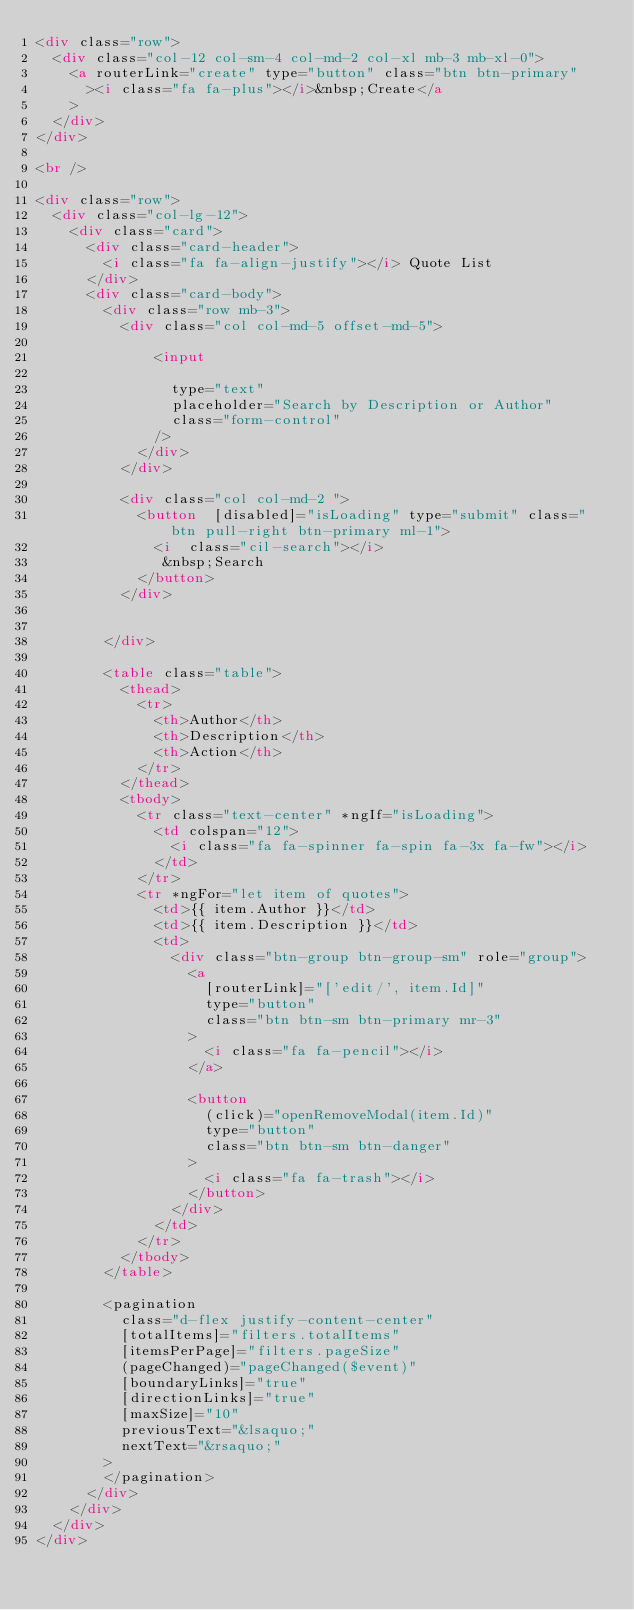<code> <loc_0><loc_0><loc_500><loc_500><_HTML_><div class="row">
  <div class="col-12 col-sm-4 col-md-2 col-xl mb-3 mb-xl-0">
    <a routerLink="create" type="button" class="btn btn-primary"
      ><i class="fa fa-plus"></i>&nbsp;Create</a
    >
  </div>
</div>

<br />

<div class="row">
  <div class="col-lg-12">
    <div class="card">
      <div class="card-header">
        <i class="fa fa-align-justify"></i> Quote List
      </div>
      <div class="card-body">
        <div class="row mb-3">
          <div class="col col-md-5 offset-md-5">
            
              <input
                
                type="text"
                placeholder="Search by Description or Author"
                class="form-control"
              />
            </div>
          </div>

          <div class="col col-md-2 ">
            <button  [disabled]="isLoading" type="submit" class="btn pull-right btn-primary ml-1">
              <i  class="cil-search"></i>
               &nbsp;Search
            </button>
          </div>


        </div>

        <table class="table">
          <thead>
            <tr>
              <th>Author</th>
              <th>Description</th>
              <th>Action</th>
            </tr>
          </thead>
          <tbody>
            <tr class="text-center" *ngIf="isLoading">
              <td colspan="12">
                <i class="fa fa-spinner fa-spin fa-3x fa-fw"></i>
              </td>
            </tr>
            <tr *ngFor="let item of quotes">
              <td>{{ item.Author }}</td>
              <td>{{ item.Description }}</td>
              <td>
                <div class="btn-group btn-group-sm" role="group">
                  <a
                    [routerLink]="['edit/', item.Id]"
                    type="button"
                    class="btn btn-sm btn-primary mr-3"
                  >
                    <i class="fa fa-pencil"></i>
                  </a>

                  <button
                    (click)="openRemoveModal(item.Id)"
                    type="button"
                    class="btn btn-sm btn-danger"
                  >
                    <i class="fa fa-trash"></i>
                  </button>
                </div>
              </td>
            </tr>
          </tbody>
        </table>

        <pagination
          class="d-flex justify-content-center"
          [totalItems]="filters.totalItems"
          [itemsPerPage]="filters.pageSize"
          (pageChanged)="pageChanged($event)"
          [boundaryLinks]="true"
          [directionLinks]="true"
          [maxSize]="10"
          previousText="&lsaquo;"
          nextText="&rsaquo;"
        >
        </pagination>
      </div>
    </div>
  </div>
</div>
</code> 